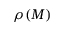Convert formula to latex. <formula><loc_0><loc_0><loc_500><loc_500>\rho ( M )</formula> 